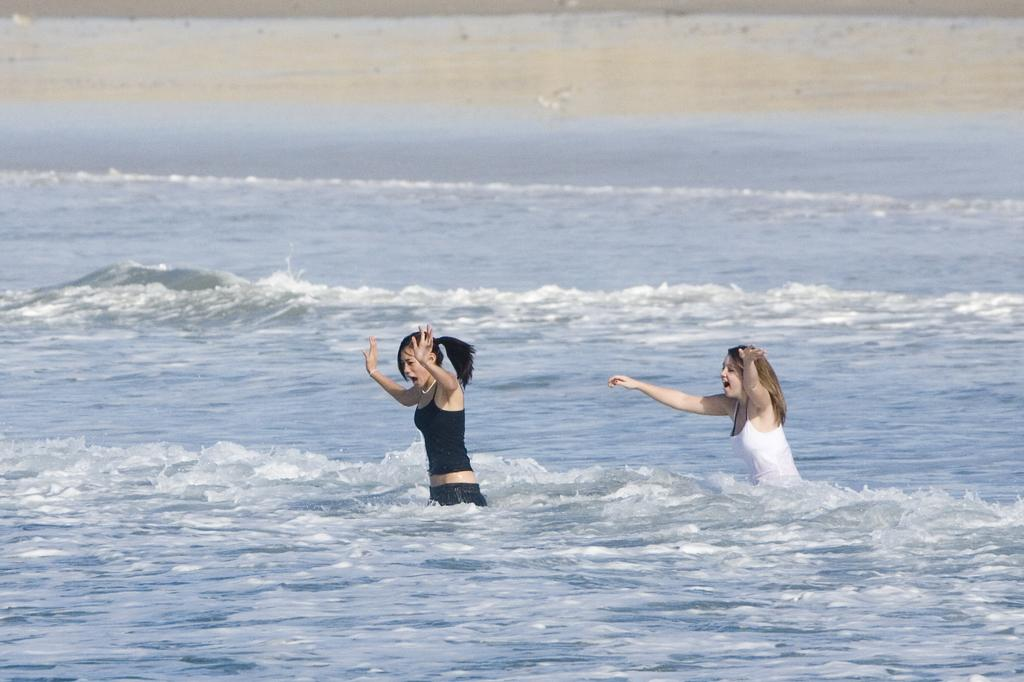How many people are in the image? There are two girls in the image. What are the girls doing in the image? The girls are standing in the water and playing with the water. What type of copper object can be seen in the image? There is no copper object present in the image. What kind of railway is visible in the image? There is no railway present in the image. 